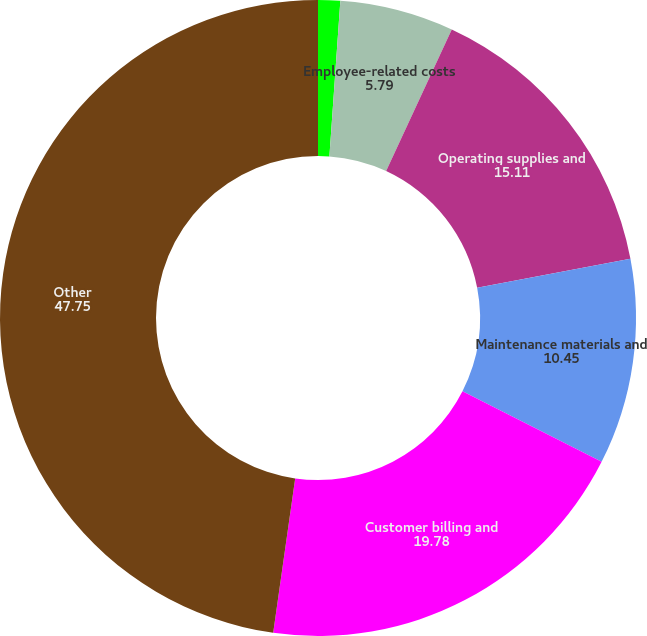Convert chart to OTSL. <chart><loc_0><loc_0><loc_500><loc_500><pie_chart><fcel>Production costs<fcel>Employee-related costs<fcel>Operating supplies and<fcel>Maintenance materials and<fcel>Customer billing and<fcel>Other<nl><fcel>1.12%<fcel>5.79%<fcel>15.11%<fcel>10.45%<fcel>19.78%<fcel>47.75%<nl></chart> 